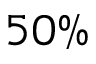Convert formula to latex. <formula><loc_0><loc_0><loc_500><loc_500>5 0 \%</formula> 